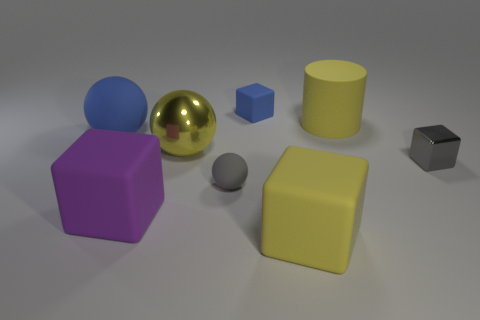The yellow metal object is what shape?
Your response must be concise. Sphere. What number of large things are cyan matte cubes or gray objects?
Offer a terse response. 0. There is a metallic thing that is the same shape as the big blue rubber thing; what size is it?
Your answer should be compact. Large. What number of big matte objects are both left of the gray matte thing and in front of the big metallic thing?
Keep it short and to the point. 1. There is a big purple rubber object; is its shape the same as the blue thing left of the small gray rubber object?
Give a very brief answer. No. Is the number of large purple matte objects in front of the purple thing greater than the number of tiny green matte things?
Ensure brevity in your answer.  No. Are there fewer matte objects in front of the big purple thing than purple matte objects?
Offer a terse response. No. What number of small matte things are the same color as the tiny metallic block?
Your answer should be compact. 1. What is the large object that is both to the left of the small blue rubber cube and in front of the metallic cube made of?
Offer a very short reply. Rubber. There is a shiny thing to the left of the tiny gray matte object; is its color the same as the shiny object that is right of the small gray ball?
Offer a terse response. No. 